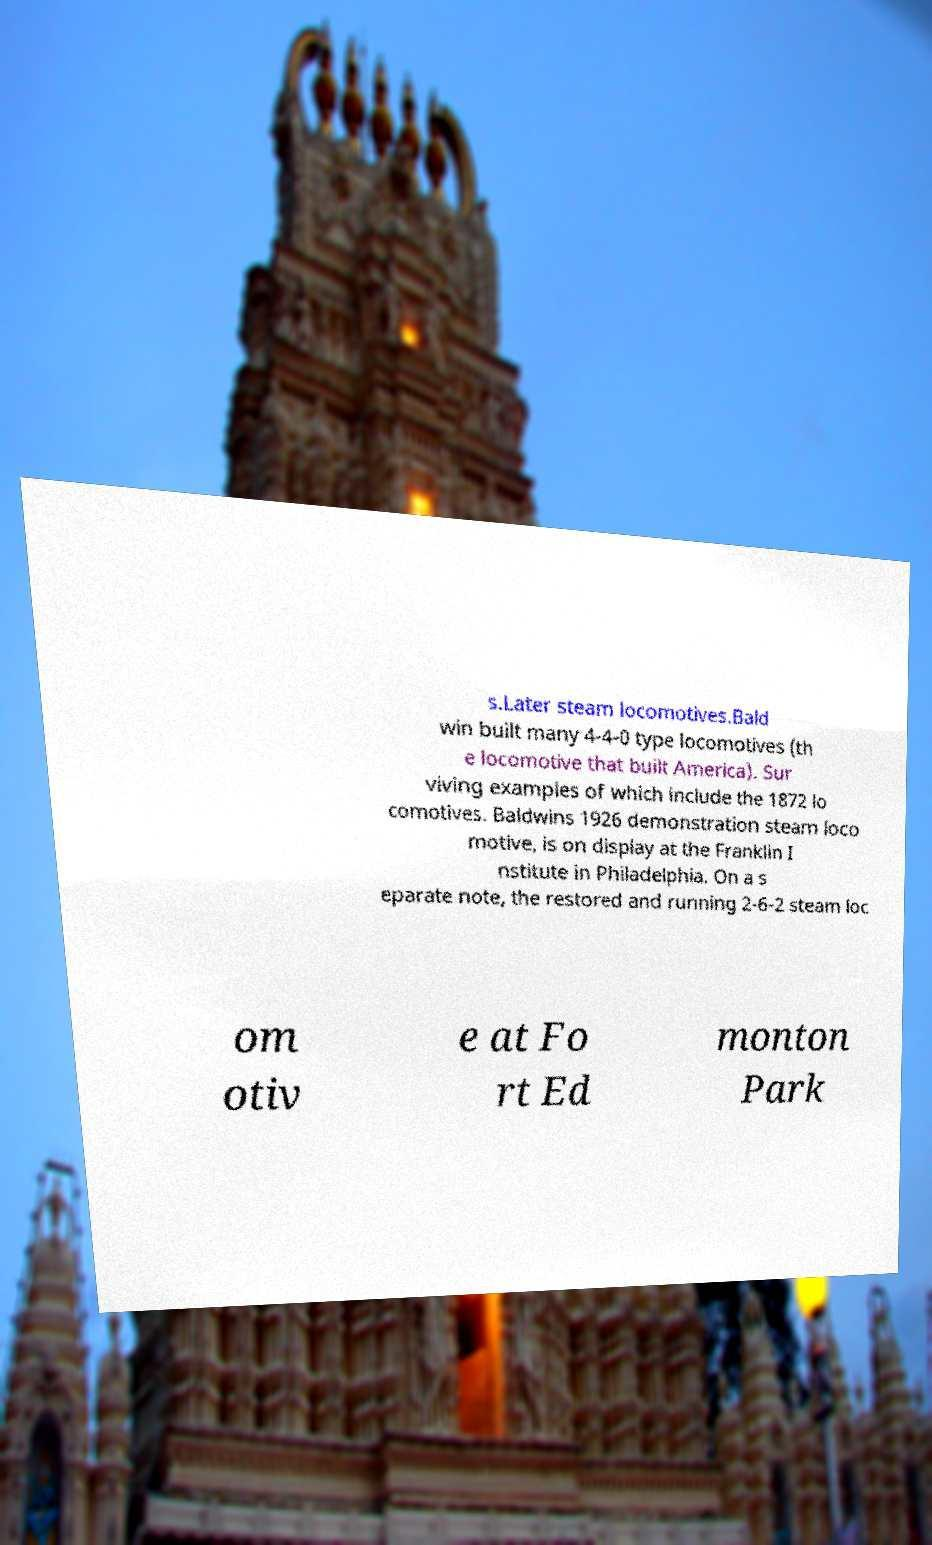Please read and relay the text visible in this image. What does it say? s.Later steam locomotives.Bald win built many 4-4-0 type locomotives (th e locomotive that built America). Sur viving examples of which include the 1872 lo comotives. Baldwins 1926 demonstration steam loco motive, is on display at the Franklin I nstitute in Philadelphia. On a s eparate note, the restored and running 2-6-2 steam loc om otiv e at Fo rt Ed monton Park 